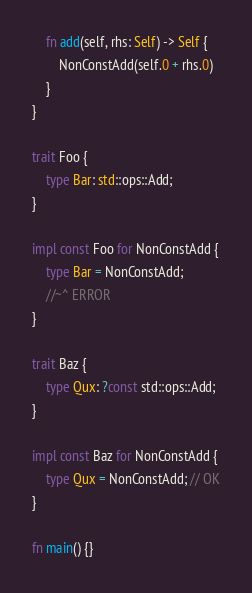<code> <loc_0><loc_0><loc_500><loc_500><_Rust_>
    fn add(self, rhs: Self) -> Self {
        NonConstAdd(self.0 + rhs.0)
    }
}

trait Foo {
    type Bar: std::ops::Add;
}

impl const Foo for NonConstAdd {
    type Bar = NonConstAdd;
    //~^ ERROR
}

trait Baz {
    type Qux: ?const std::ops::Add;
}

impl const Baz for NonConstAdd {
    type Qux = NonConstAdd; // OK
}

fn main() {}
</code> 